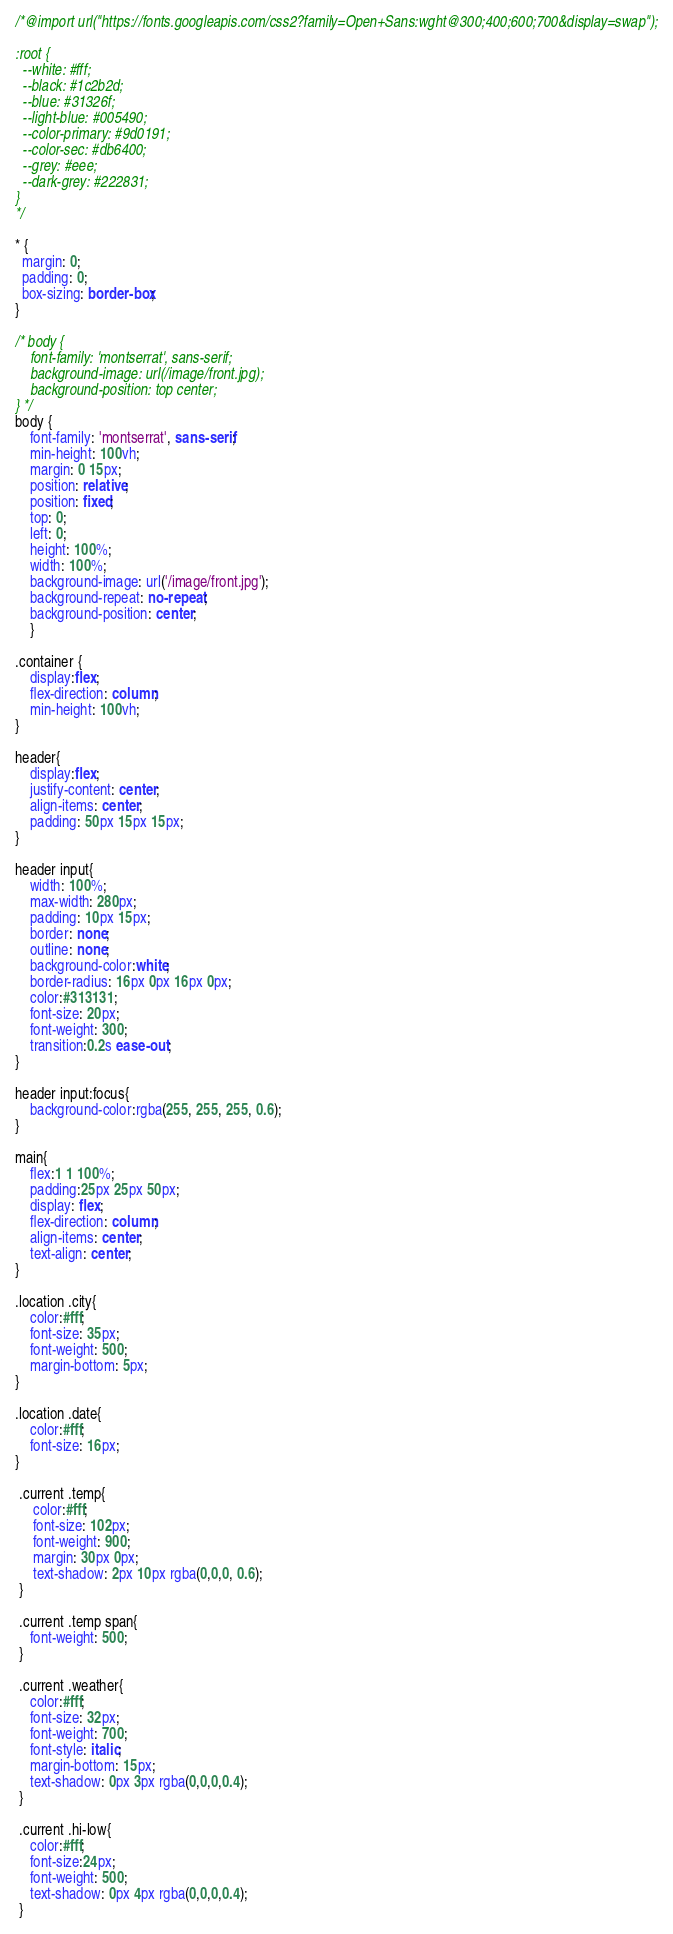Convert code to text. <code><loc_0><loc_0><loc_500><loc_500><_CSS_>/*@import url("https://fonts.googleapis.com/css2?family=Open+Sans:wght@300;400;600;700&display=swap");

:root {
  --white: #fff;
  --black: #1c2b2d;
  --blue: #31326f;
  --light-blue: #005490;
  --color-primary: #9d0191;
  --color-sec: #db6400;
  --grey: #eee;
  --dark-grey: #222831;
}
*/

* {
  margin: 0;
  padding: 0;
  box-sizing: border-box;
}

/* body {
    font-family: 'montserrat', sans-serif;
    background-image: url(/image/front.jpg);
    background-position: top center; 
} */
body {
    font-family: 'montserrat', sans-serif;
    min-height: 100vh;
    margin: 0 15px;
    position: relative; 
    position: fixed;
    top: 0;
    left: 0;
    height: 100%;
    width: 100%;
    background-image: url('/image/front.jpg');
    background-repeat: no-repeat;
    background-position: center;
    }

.container {
    display:flex;
    flex-direction: column;
    min-height: 100vh;    
}

header{
    display:flex;
    justify-content: center;
    align-items: center;
    padding: 50px 15px 15px;
}

header input{
    width: 100%;
    max-width: 280px;
    padding: 10px 15px;
    border: none;
    outline: none;
    background-color:white;
    border-radius: 16px 0px 16px 0px;
    color:#313131;
    font-size: 20px;
    font-weight: 300;
    transition:0.2s ease-out;
}

header input:focus{
    background-color:rgba(255, 255, 255, 0.6);
}

main{
    flex:1 1 100%;
    padding:25px 25px 50px;
    display: flex;
    flex-direction: column;
    align-items: center;
    text-align: center;
}

.location .city{
    color:#fff;
    font-size: 35px;
    font-weight: 500;
    margin-bottom: 5px;
}

.location .date{
    color:#fff;
    font-size: 16px;
}

 .current .temp{
     color:#fff;
     font-size: 102px;
     font-weight: 900;
     margin: 30px 0px;
     text-shadow: 2px 10px rgba(0,0,0, 0.6);
 }

 .current .temp span{
    font-weight: 500;
 }

 .current .weather{
    color:#fff;
    font-size: 32px;
    font-weight: 700;
    font-style: italic;
    margin-bottom: 15px;
    text-shadow: 0px 3px rgba(0,0,0,0.4);
 }

 .current .hi-low{
    color:#fff;
    font-size:24px;
    font-weight: 500;
    text-shadow: 0px 4px rgba(0,0,0,0.4);
 }


</code> 